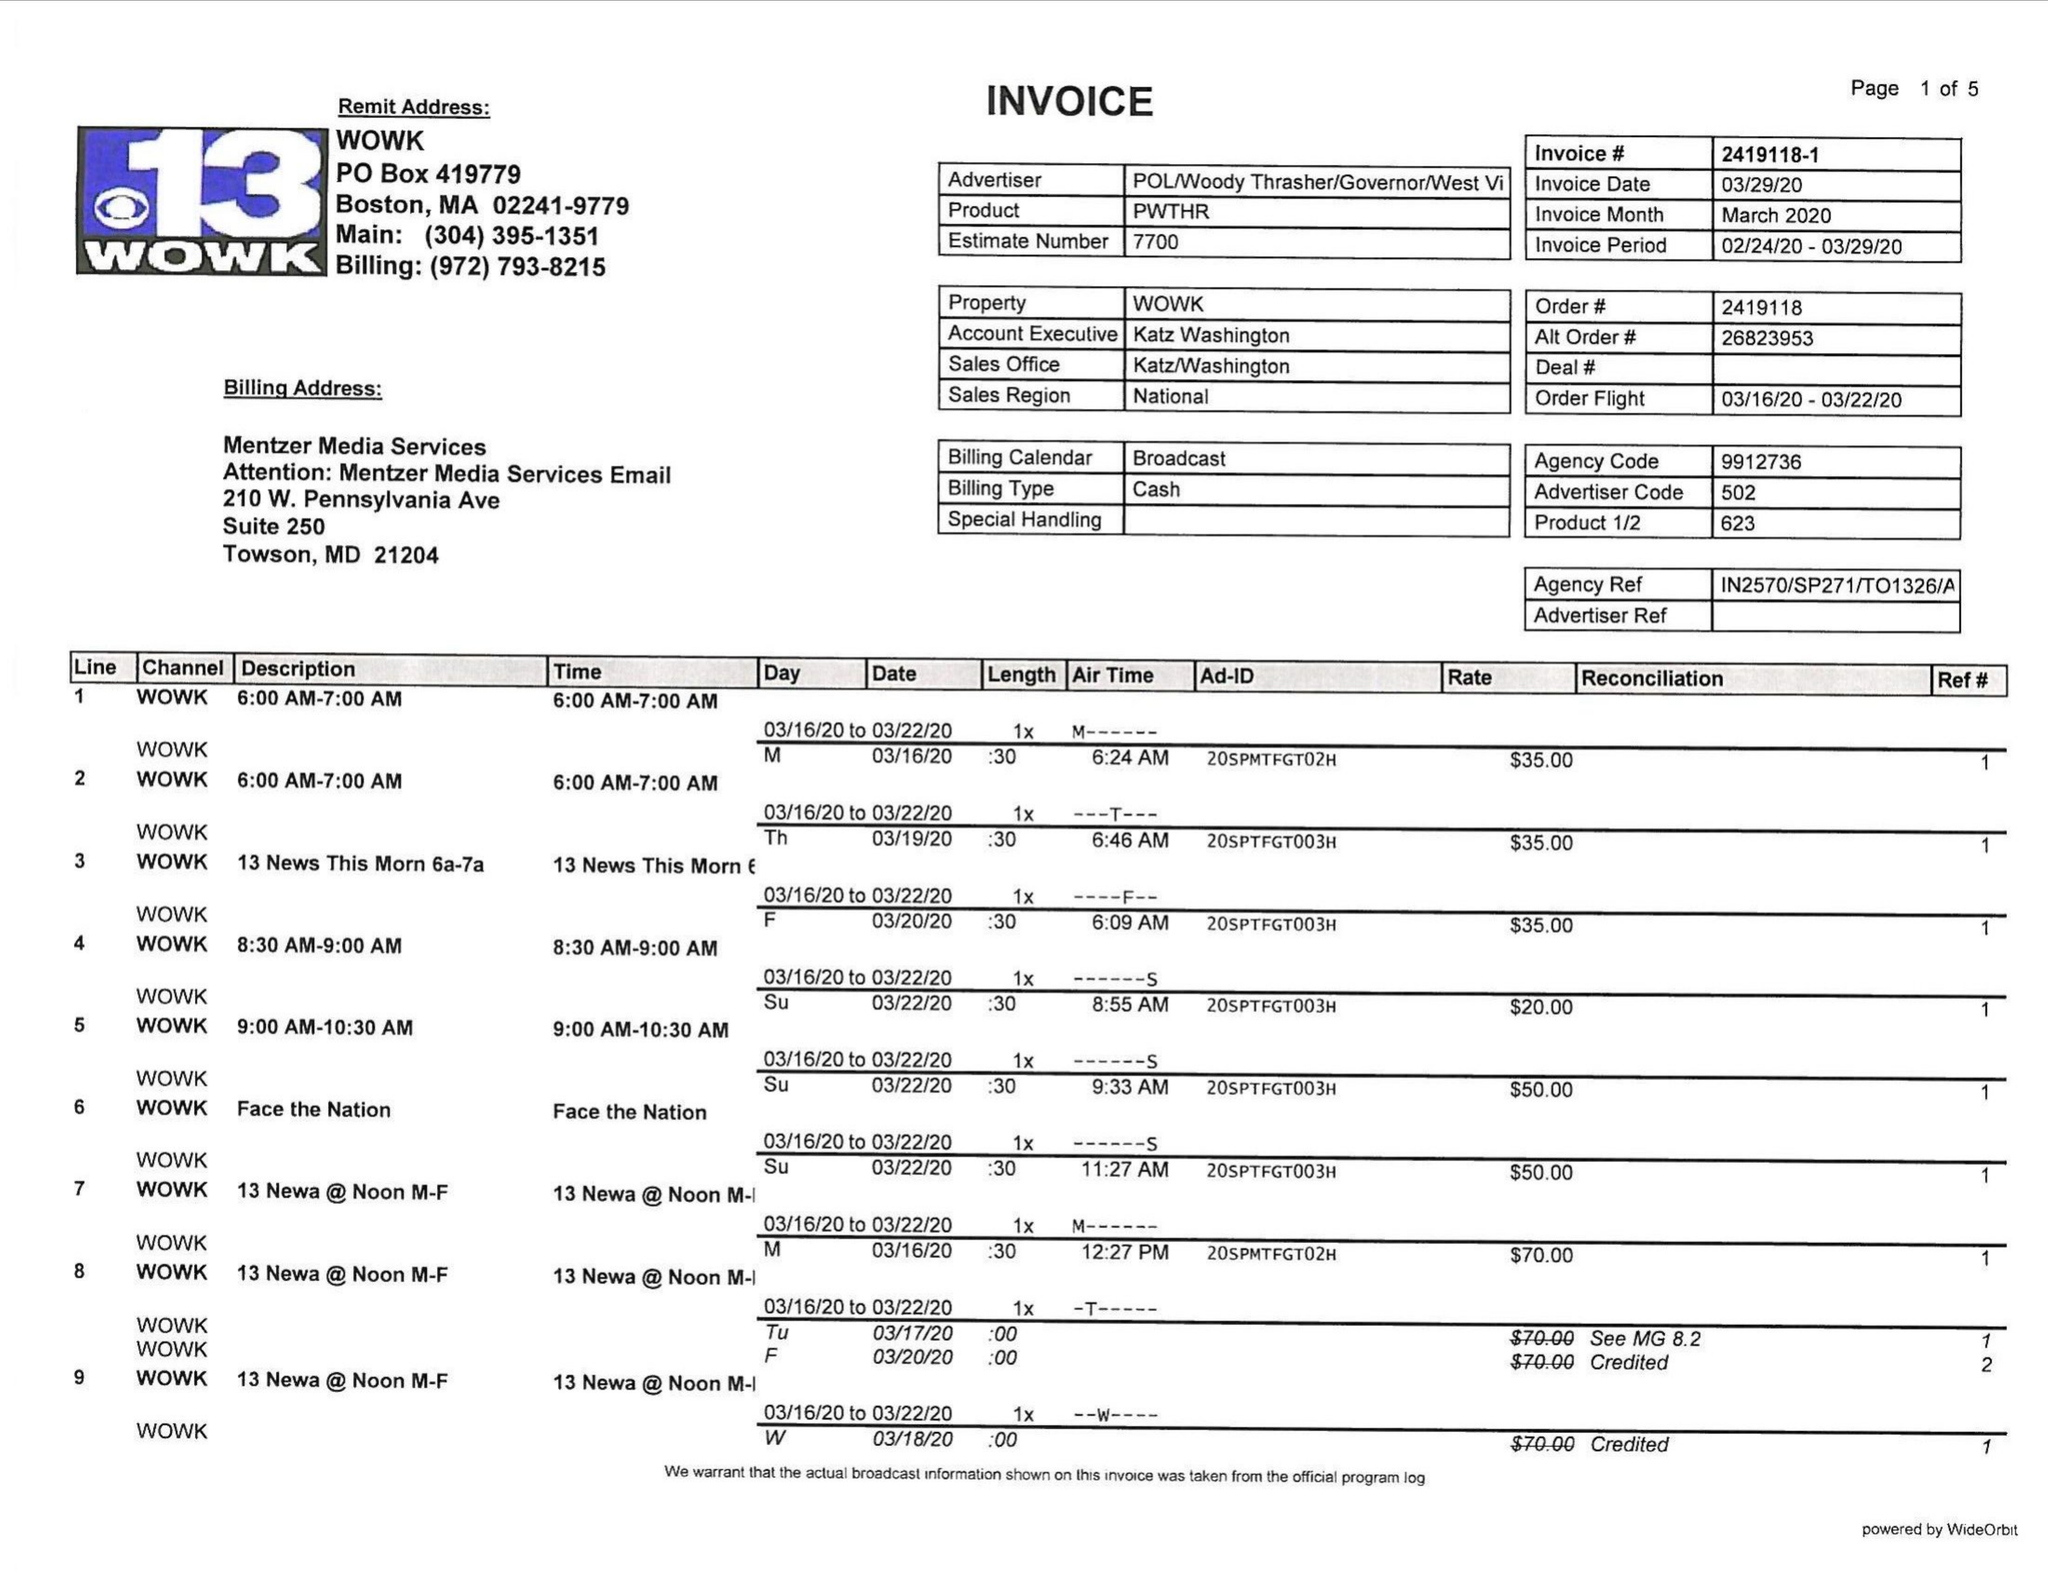What is the value for the advertiser?
Answer the question using a single word or phrase. POL/WOODYTHRASHER/GOVERNOR/WESTVI 